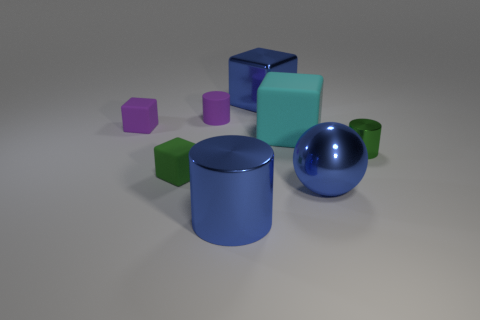There is a metallic cylinder to the left of the cyan thing; what size is it?
Provide a short and direct response. Large. Does the sphere have the same color as the matte cylinder?
Keep it short and to the point. No. How many large things are either objects or cyan rubber balls?
Provide a short and direct response. 4. Are there any other things that are the same color as the big metal block?
Give a very brief answer. Yes. Are there any things to the right of the green shiny thing?
Your answer should be very brief. No. There is a blue thing that is behind the purple thing that is to the right of the green block; what size is it?
Give a very brief answer. Large. Are there the same number of big spheres that are to the left of the blue cube and cubes to the right of the blue metal cylinder?
Provide a succinct answer. No. There is a cube that is right of the blue metallic cube; is there a big matte thing behind it?
Make the answer very short. No. There is a large metal object on the right side of the big metallic object that is behind the green metallic thing; what number of big blue metal things are on the left side of it?
Provide a short and direct response. 2. Are there fewer small cubes than large shiny things?
Ensure brevity in your answer.  Yes. 